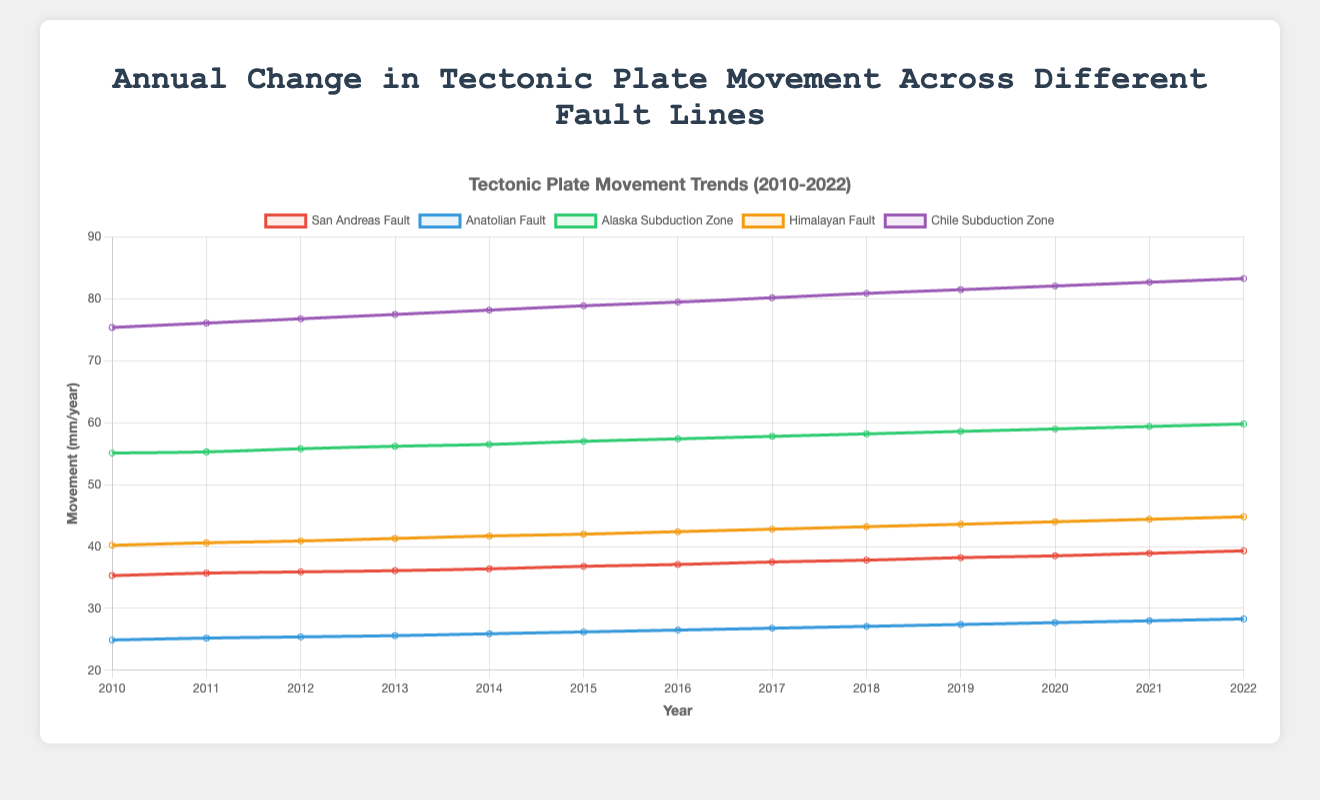What's the average annual movement of the San Andreas Fault from 2010 to 2022? To calculate the average, sum up the annual movements and divide by the number of years. The sum is (35.3 + 35.7 + 35.9 + 36.1 + 36.4 + 36.8 + 37.1 + 37.5 + 37.8 + 38.2 + 38.5 + 38.9 + 39.3) = 478.5. There are 13 years, so the average is 478.5 / 13 ≈ 36.81.
Answer: 36.81 Which fault line has the greatest increase in movement from 2010 to 2022? Calculate the difference in movement from 2010 to 2022 for each fault line. The differences are: San Andreas Fault (39.3 - 35.3) = 4.0, Anatolian Fault (28.3 - 24.9) = 3.4, Alaska Subduction Zone (59.8 - 55.1) = 4.7, Himalayan Fault (44.8 - 40.2) = 4.6, Chile Subduction Zone (83.3 - 75.4) = 7.9. The greatest increase is for the Chile Subduction Zone.
Answer: Chile Subduction Zone Which fault line has the highest movement rate in 2022? Check the movement data for 2022 for all fault lines: San Andreas Fault (39.3), Anatolian Fault (28.3), Alaska Subduction Zone (59.8), Himalayan Fault (44.8), Chile Subduction Zone (83.3). The highest value is 83.3 for the Chile Subduction Zone.
Answer: Chile Subduction Zone Which fault line shows a consistently increasing trend from 2010 to 2022? By examining the lines on the chart, we can see that all fault lines show a consistent increasing trend over the years.
Answer: All fault lines How much more did the Chile Subduction Zone move compared to the San Andreas Fault in 2022? Subtract the movement of the San Andreas Fault from the Chile Subduction Zone in 2022. The calculation is 83.3 - 39.3 = 44.
Answer: 44 What is the total annual movement across all fault lines in 2015? Sum the movement data for 2015 for all fault lines: (36.8 + 26.2 + 57.0 + 42.0 + 78.9) = 240.9.
Answer: 240.9 What is the average annual movement for the Himalayan Fault between 2010 and 2022? Sum the annual movements for the Himalayan Fault and divide by the number of years: The sum is (40.2 + 40.6 + 40.9 + 41.3 + 41.7 + 42.0 + 42.4 + 42.8 + 43.2 + 43.6 + 44.0 + 44.4 + 44.8) = 552.9. There are 13 years, so the average is 552.9 / 13 ≈ 42.53.
Answer: 42.53 